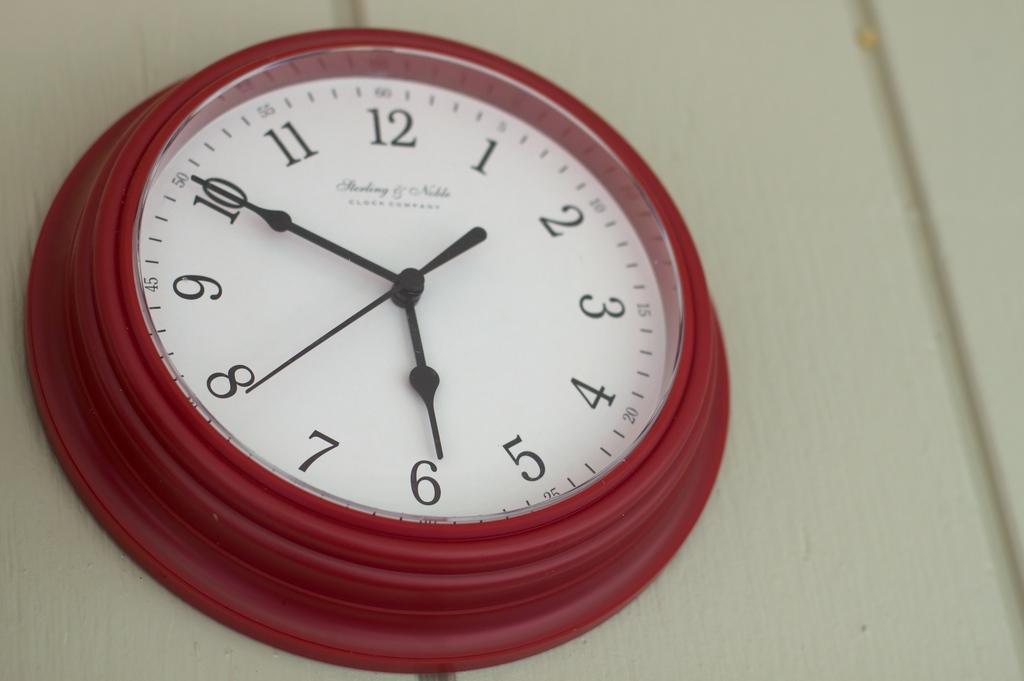What time is it on the clock?
Offer a terse response. 5:50. What time does the second hand show?
Your answer should be compact. 39. 